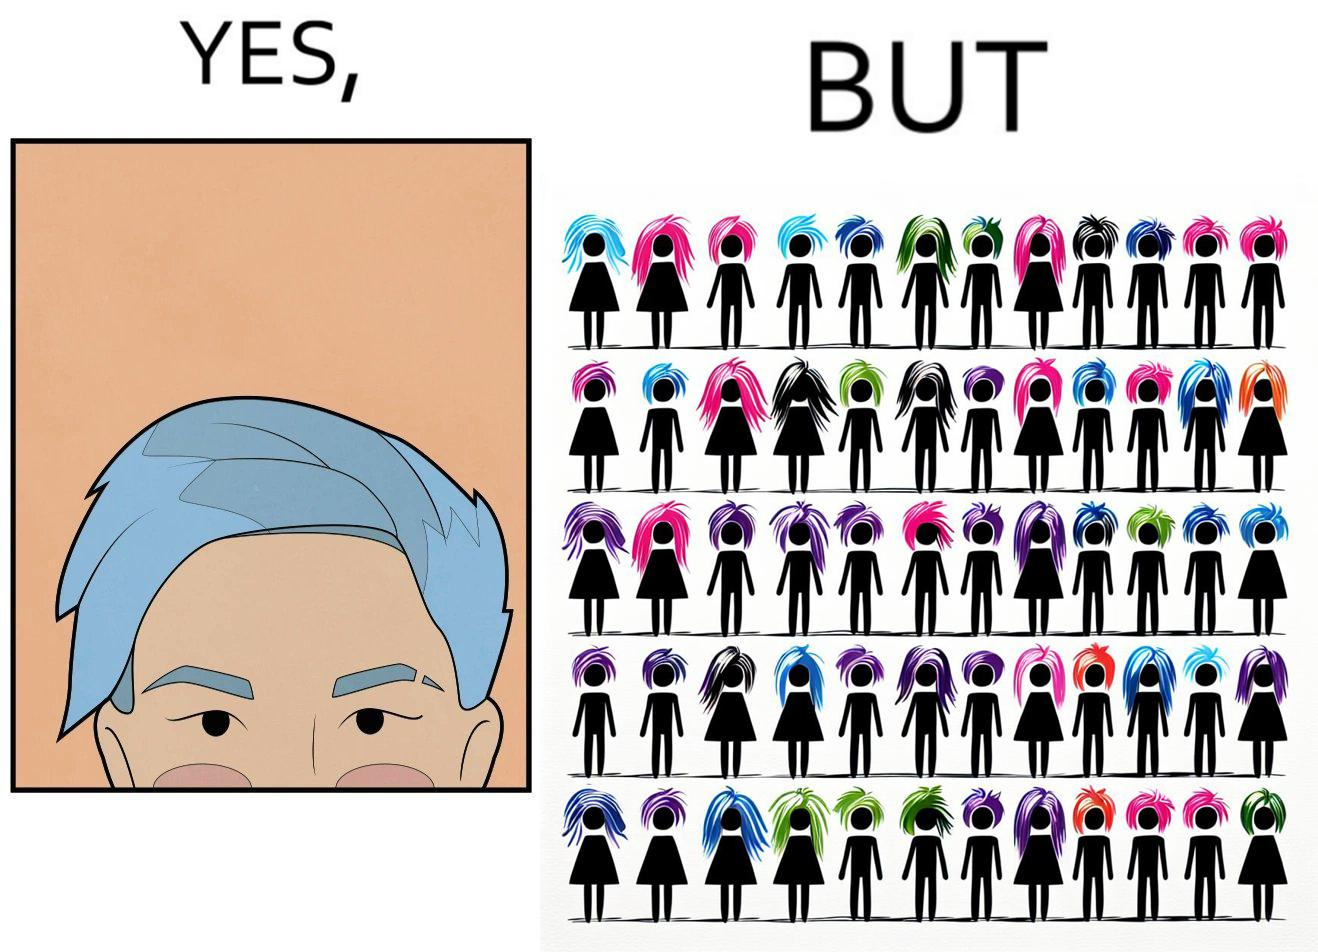Why is this image considered satirical? The image is funny, as one person with a hair dyed blue seems to symbolize that the person is going against the grain, however, when we zoom out, the group of people have hair dyed in several, different colors, showing that, dyeing hair is the new normal. 